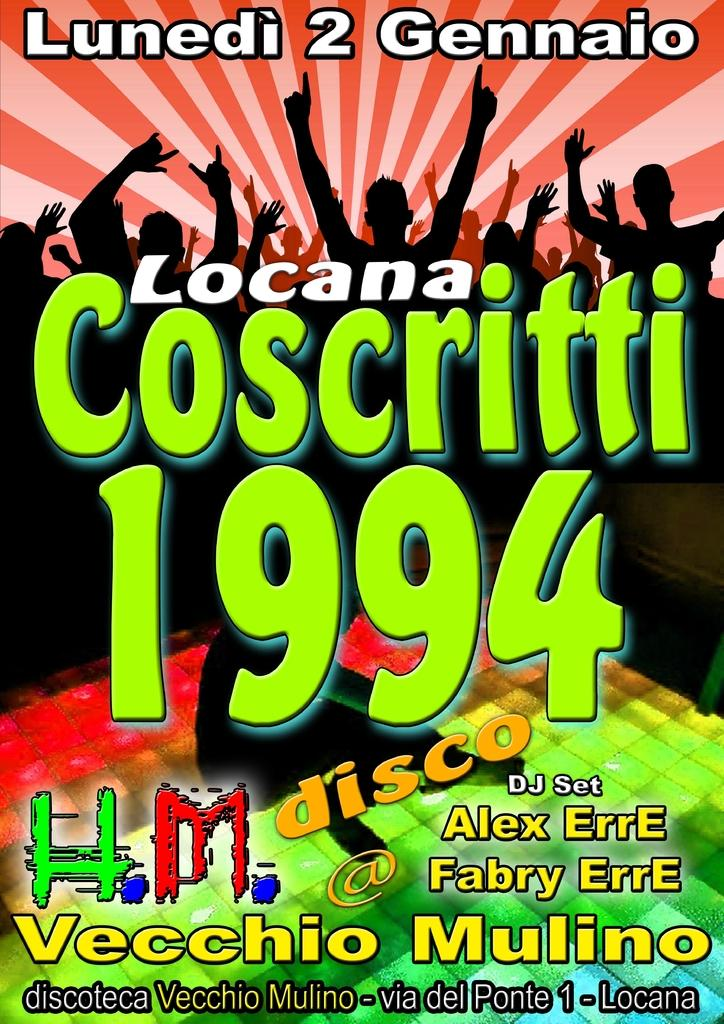Provide a one-sentence caption for the provided image. The poster advertises a disco with a DJ called Alex Erre and Fabry Erre. 